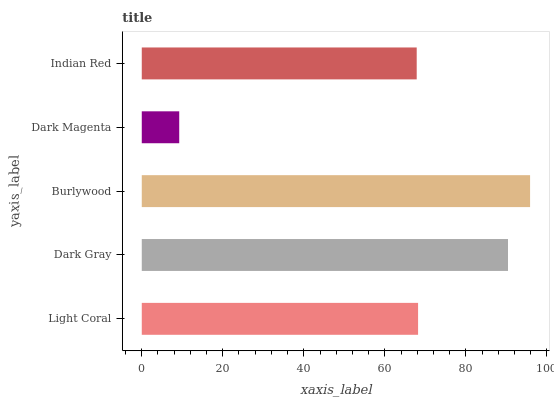Is Dark Magenta the minimum?
Answer yes or no. Yes. Is Burlywood the maximum?
Answer yes or no. Yes. Is Dark Gray the minimum?
Answer yes or no. No. Is Dark Gray the maximum?
Answer yes or no. No. Is Dark Gray greater than Light Coral?
Answer yes or no. Yes. Is Light Coral less than Dark Gray?
Answer yes or no. Yes. Is Light Coral greater than Dark Gray?
Answer yes or no. No. Is Dark Gray less than Light Coral?
Answer yes or no. No. Is Light Coral the high median?
Answer yes or no. Yes. Is Light Coral the low median?
Answer yes or no. Yes. Is Dark Gray the high median?
Answer yes or no. No. Is Burlywood the low median?
Answer yes or no. No. 